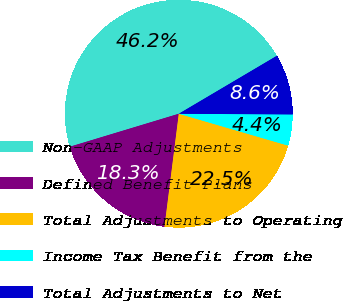<chart> <loc_0><loc_0><loc_500><loc_500><pie_chart><fcel>Non-GAAP Adjustments<fcel>Defined Benefit Plans<fcel>Total Adjustments to Operating<fcel>Income Tax Benefit from the<fcel>Total Adjustments to Net<nl><fcel>46.18%<fcel>18.32%<fcel>22.49%<fcel>4.42%<fcel>8.59%<nl></chart> 